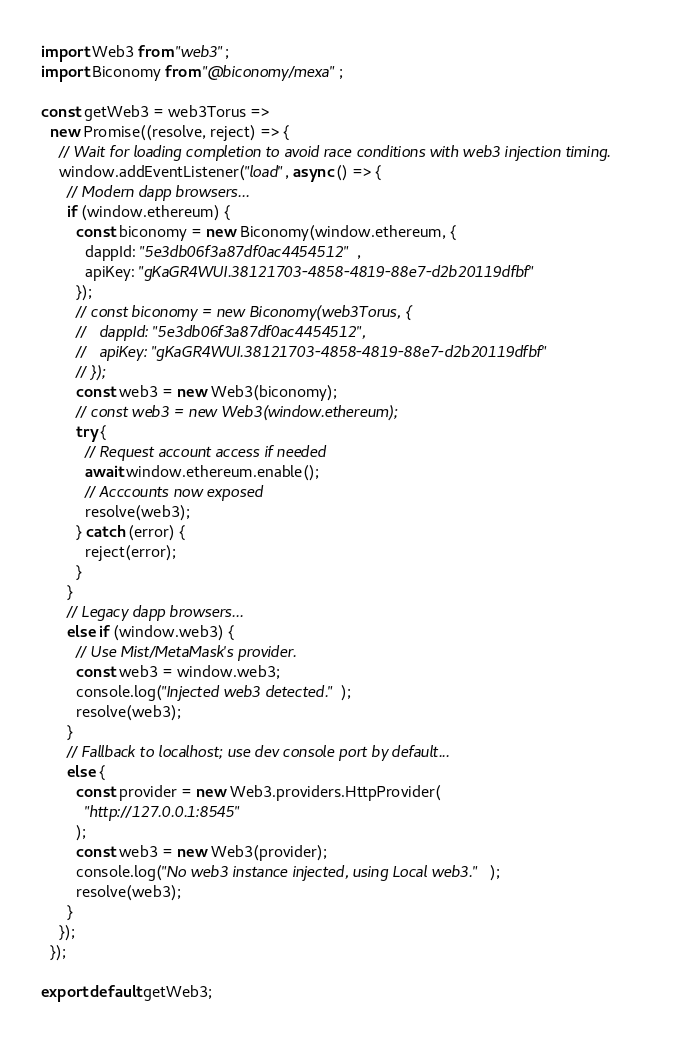<code> <loc_0><loc_0><loc_500><loc_500><_JavaScript_>import Web3 from "web3";
import Biconomy from "@biconomy/mexa";

const getWeb3 = web3Torus =>
  new Promise((resolve, reject) => {
    // Wait for loading completion to avoid race conditions with web3 injection timing.
    window.addEventListener("load", async () => {
      // Modern dapp browsers...
      if (window.ethereum) {
        const biconomy = new Biconomy(window.ethereum, {
          dappId: "5e3db06f3a87df0ac4454512",
          apiKey: "gKaGR4WUI.38121703-4858-4819-88e7-d2b20119dfbf"
        });
        // const biconomy = new Biconomy(web3Torus, {
        //   dappId: "5e3db06f3a87df0ac4454512",
        //   apiKey: "gKaGR4WUI.38121703-4858-4819-88e7-d2b20119dfbf"
        // });
        const web3 = new Web3(biconomy);
        // const web3 = new Web3(window.ethereum);
        try {
          // Request account access if needed
          await window.ethereum.enable();
          // Acccounts now exposed
          resolve(web3);
        } catch (error) {
          reject(error);
        }
      }
      // Legacy dapp browsers...
      else if (window.web3) {
        // Use Mist/MetaMask's provider.
        const web3 = window.web3;
        console.log("Injected web3 detected.");
        resolve(web3);
      }
      // Fallback to localhost; use dev console port by default...
      else {
        const provider = new Web3.providers.HttpProvider(
          "http://127.0.0.1:8545"
        );
        const web3 = new Web3(provider);
        console.log("No web3 instance injected, using Local web3.");
        resolve(web3);
      }
    });
  });

export default getWeb3;
</code> 